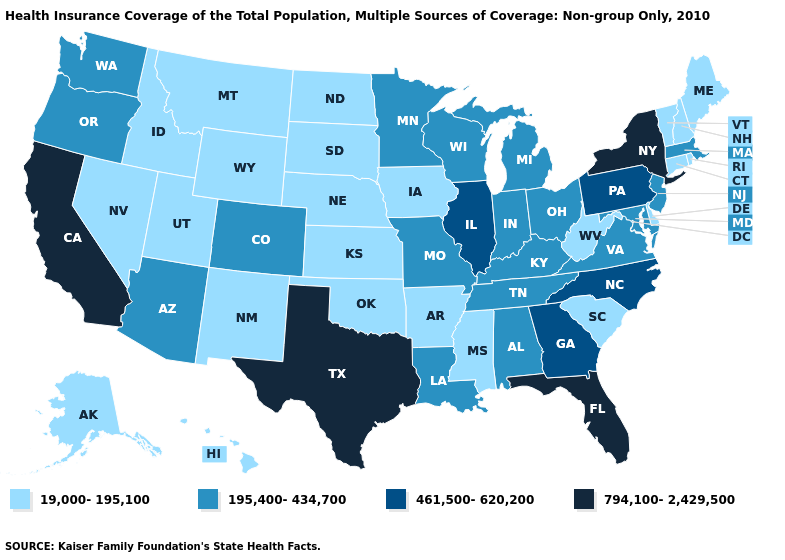What is the value of Wyoming?
Keep it brief. 19,000-195,100. Is the legend a continuous bar?
Answer briefly. No. Does Wisconsin have a lower value than Arizona?
Quick response, please. No. Among the states that border Maryland , which have the highest value?
Short answer required. Pennsylvania. Name the states that have a value in the range 195,400-434,700?
Keep it brief. Alabama, Arizona, Colorado, Indiana, Kentucky, Louisiana, Maryland, Massachusetts, Michigan, Minnesota, Missouri, New Jersey, Ohio, Oregon, Tennessee, Virginia, Washington, Wisconsin. Does Rhode Island have the highest value in the Northeast?
Concise answer only. No. Among the states that border Arizona , which have the highest value?
Be succinct. California. Does Wisconsin have the lowest value in the USA?
Keep it brief. No. Does Texas have the lowest value in the USA?
Write a very short answer. No. What is the value of South Carolina?
Answer briefly. 19,000-195,100. What is the value of Mississippi?
Give a very brief answer. 19,000-195,100. How many symbols are there in the legend?
Keep it brief. 4. Which states have the lowest value in the Northeast?
Concise answer only. Connecticut, Maine, New Hampshire, Rhode Island, Vermont. What is the lowest value in states that border Pennsylvania?
Answer briefly. 19,000-195,100. What is the value of Virginia?
Quick response, please. 195,400-434,700. 